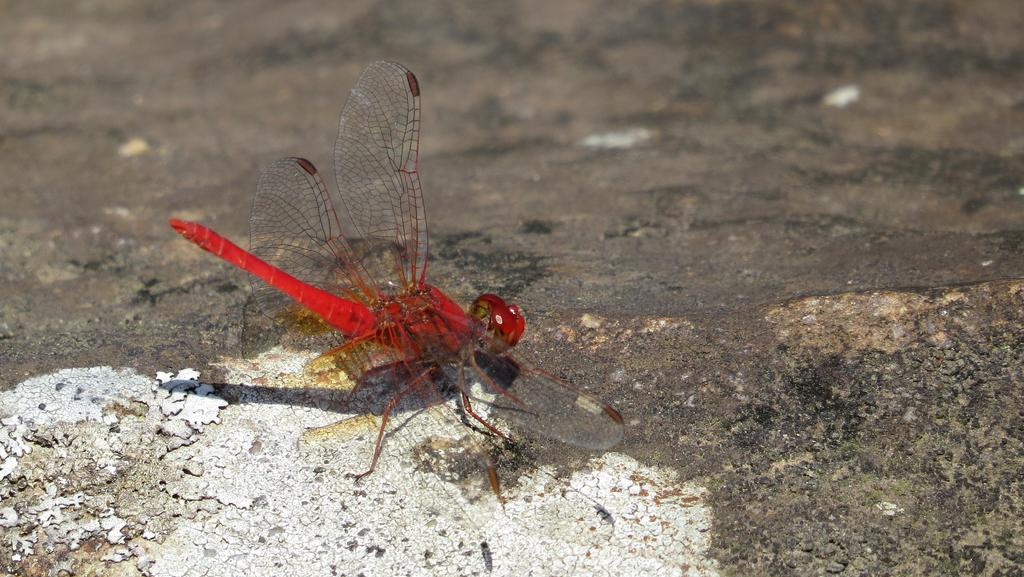What is the main subject of the image? There is a dragonfly in the image. Where is the dragonfly located in the image? The dragonfly is in the center of the image. What color is the dragonfly? The dragonfly is red in color. What type of argument can be seen taking place between the dragonfly and the flower in the image? There is no argument or flower present in the image; it features a red dragonfly in the center. 